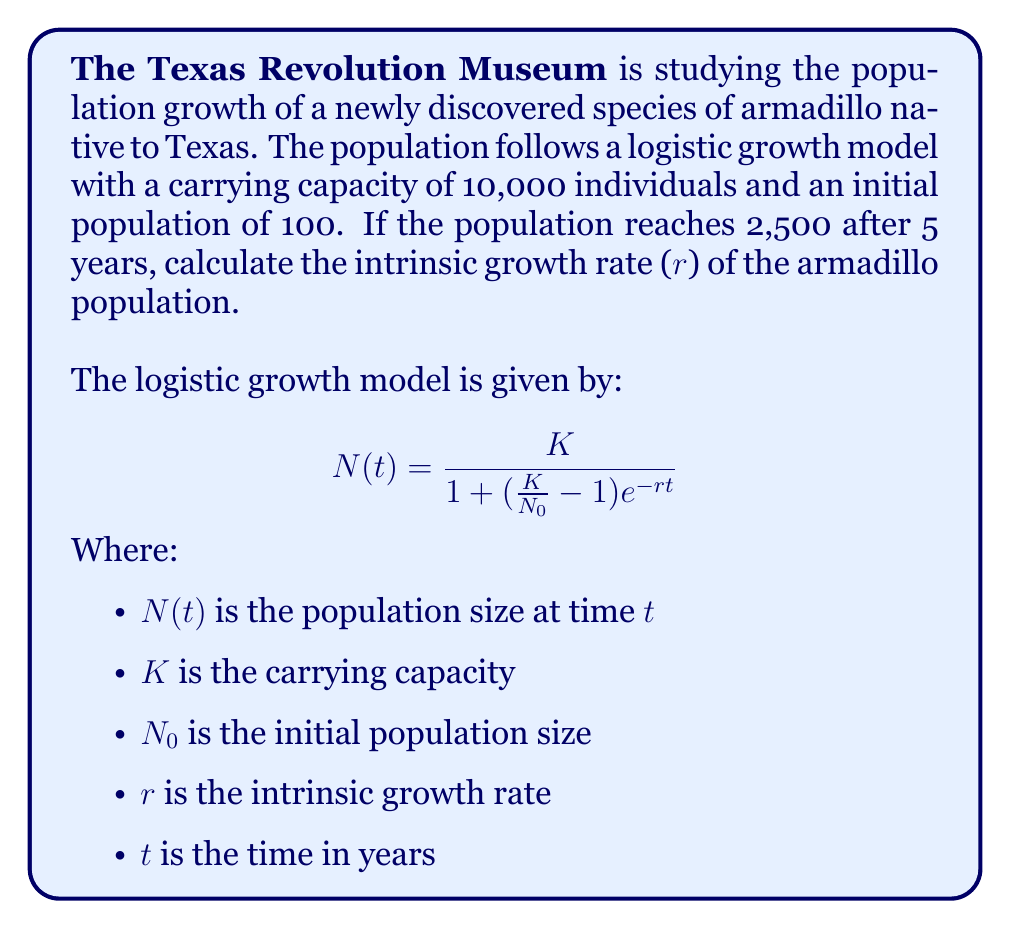Solve this math problem. Let's solve this step-by-step:

1) We know the following:
   $K = 10,000$ (carrying capacity)
   $N_0 = 100$ (initial population)
   $N(5) = 2,500$ (population after 5 years)
   $t = 5$ (time in years)

2) Let's substitute these values into the logistic growth equation:

   $$2,500 = \frac{10,000}{1 + (\frac{10,000}{100} - 1)e^{-5r}}$$

3) Simplify:

   $$2,500 = \frac{10,000}{1 + 99e^{-5r}}$$

4) Multiply both sides by $(1 + 99e^{-5r})$:

   $$2,500(1 + 99e^{-5r}) = 10,000$$

5) Expand:

   $$2,500 + 247,500e^{-5r} = 10,000$$

6) Subtract 2,500 from both sides:

   $$247,500e^{-5r} = 7,500$$

7) Divide both sides by 247,500:

   $$e^{-5r} = \frac{7,500}{247,500} = 0.0303$$

8) Take the natural log of both sides:

   $$-5r = \ln(0.0303)$$

9) Divide both sides by -5:

   $$r = -\frac{\ln(0.0303)}{5} \approx 0.6931$$

Therefore, the intrinsic growth rate (r) is approximately 0.6931 per year.
Answer: $r \approx 0.6931$ per year 